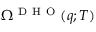<formula> <loc_0><loc_0><loc_500><loc_500>\Omega ^ { D H O } ( q ; T )</formula> 